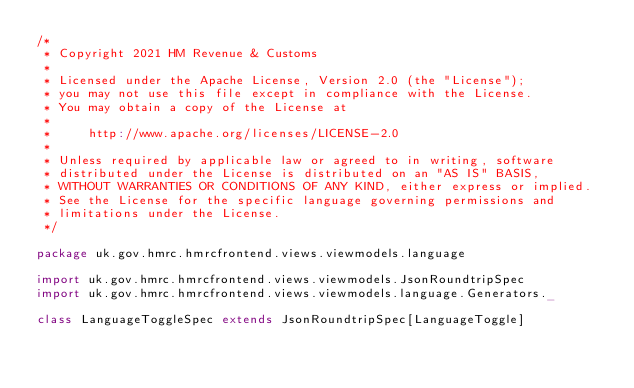Convert code to text. <code><loc_0><loc_0><loc_500><loc_500><_Scala_>/*
 * Copyright 2021 HM Revenue & Customs
 *
 * Licensed under the Apache License, Version 2.0 (the "License");
 * you may not use this file except in compliance with the License.
 * You may obtain a copy of the License at
 *
 *     http://www.apache.org/licenses/LICENSE-2.0
 *
 * Unless required by applicable law or agreed to in writing, software
 * distributed under the License is distributed on an "AS IS" BASIS,
 * WITHOUT WARRANTIES OR CONDITIONS OF ANY KIND, either express or implied.
 * See the License for the specific language governing permissions and
 * limitations under the License.
 */

package uk.gov.hmrc.hmrcfrontend.views.viewmodels.language

import uk.gov.hmrc.hmrcfrontend.views.viewmodels.JsonRoundtripSpec
import uk.gov.hmrc.hmrcfrontend.views.viewmodels.language.Generators._

class LanguageToggleSpec extends JsonRoundtripSpec[LanguageToggle]
</code> 